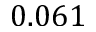<formula> <loc_0><loc_0><loc_500><loc_500>0 . 0 6 1</formula> 